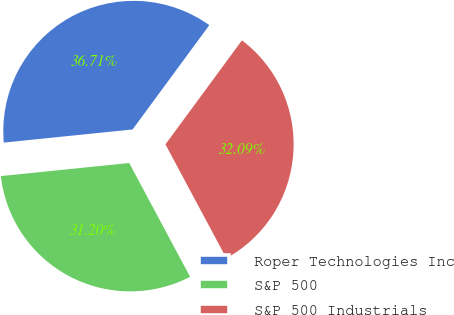Convert chart to OTSL. <chart><loc_0><loc_0><loc_500><loc_500><pie_chart><fcel>Roper Technologies Inc<fcel>S&P 500<fcel>S&P 500 Industrials<nl><fcel>36.71%<fcel>31.2%<fcel>32.09%<nl></chart> 